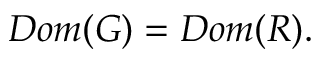<formula> <loc_0><loc_0><loc_500><loc_500>D o m ( G ) = D o m ( R ) .</formula> 